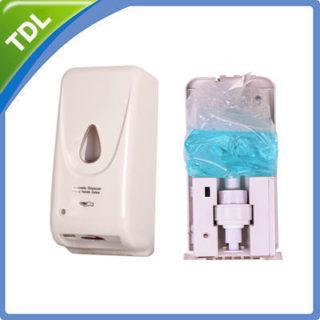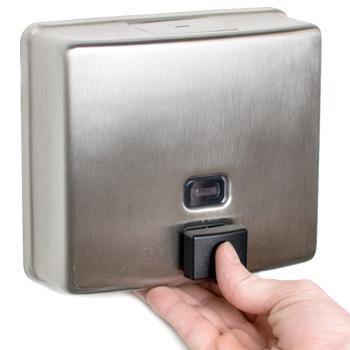The first image is the image on the left, the second image is the image on the right. Evaluate the accuracy of this statement regarding the images: "The left and right image contains the same number of metal wall soap dispensers.". Is it true? Answer yes or no. No. The first image is the image on the left, the second image is the image on the right. For the images displayed, is the sentence "The left image features a narrower rectangular dispenser with a circle above a dark rectangular button, and the right image features a more square dispenser with a rectangle above the rectangular button on the bottom." factually correct? Answer yes or no. No. 